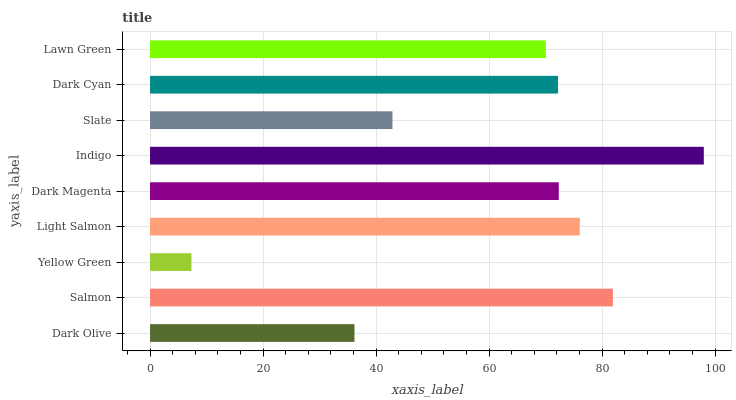Is Yellow Green the minimum?
Answer yes or no. Yes. Is Indigo the maximum?
Answer yes or no. Yes. Is Salmon the minimum?
Answer yes or no. No. Is Salmon the maximum?
Answer yes or no. No. Is Salmon greater than Dark Olive?
Answer yes or no. Yes. Is Dark Olive less than Salmon?
Answer yes or no. Yes. Is Dark Olive greater than Salmon?
Answer yes or no. No. Is Salmon less than Dark Olive?
Answer yes or no. No. Is Dark Cyan the high median?
Answer yes or no. Yes. Is Dark Cyan the low median?
Answer yes or no. Yes. Is Indigo the high median?
Answer yes or no. No. Is Indigo the low median?
Answer yes or no. No. 